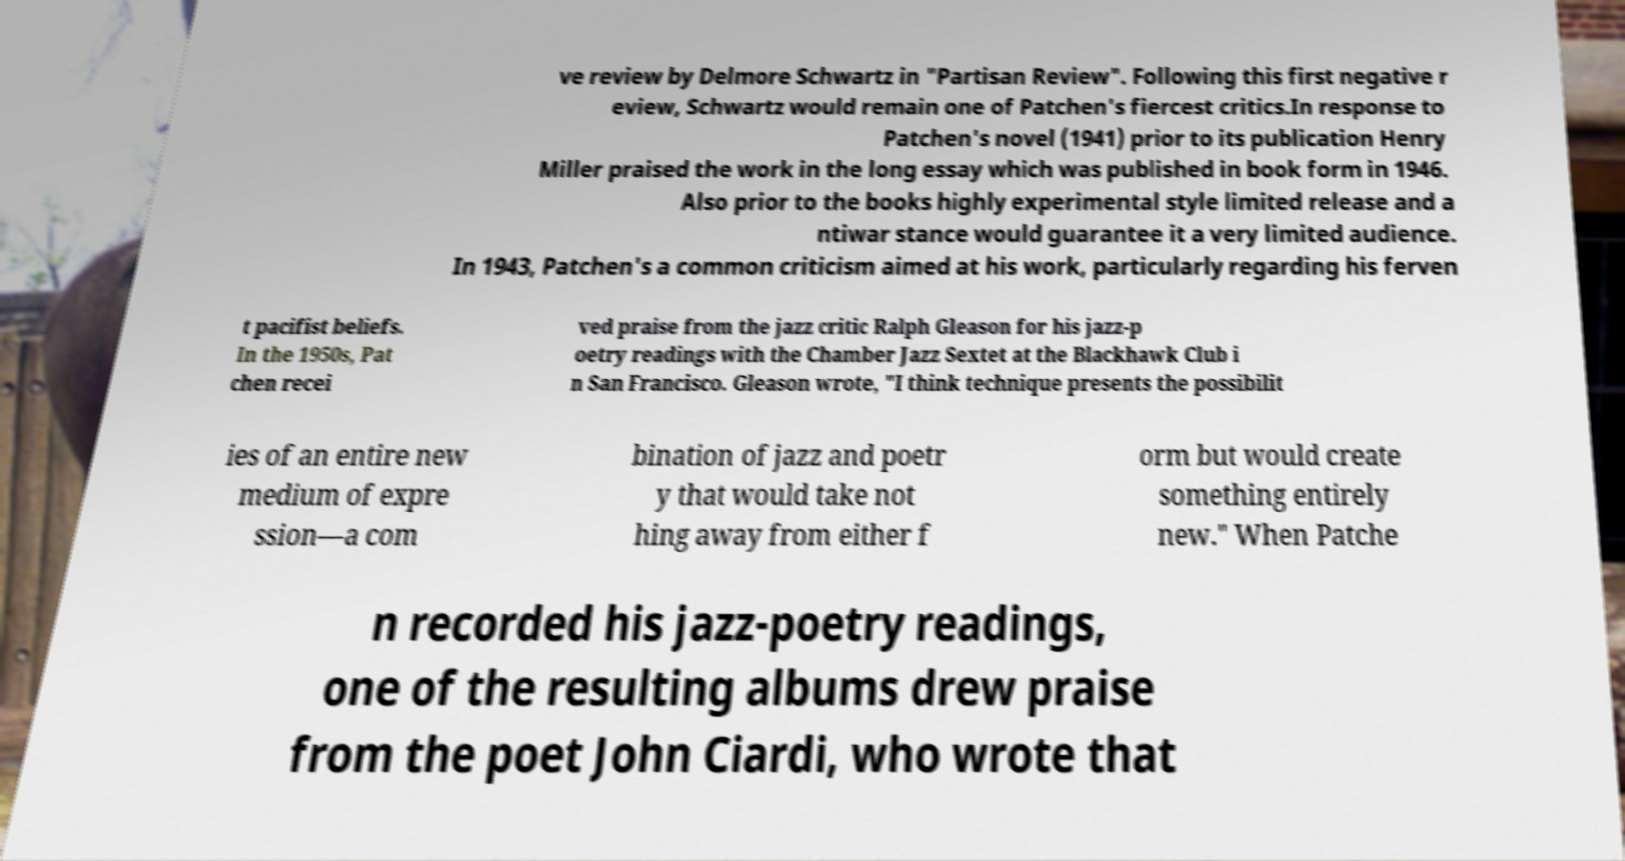I need the written content from this picture converted into text. Can you do that? ve review by Delmore Schwartz in "Partisan Review". Following this first negative r eview, Schwartz would remain one of Patchen's fiercest critics.In response to Patchen's novel (1941) prior to its publication Henry Miller praised the work in the long essay which was published in book form in 1946. Also prior to the books highly experimental style limited release and a ntiwar stance would guarantee it a very limited audience. In 1943, Patchen's a common criticism aimed at his work, particularly regarding his ferven t pacifist beliefs. In the 1950s, Pat chen recei ved praise from the jazz critic Ralph Gleason for his jazz-p oetry readings with the Chamber Jazz Sextet at the Blackhawk Club i n San Francisco. Gleason wrote, "I think technique presents the possibilit ies of an entire new medium of expre ssion―a com bination of jazz and poetr y that would take not hing away from either f orm but would create something entirely new." When Patche n recorded his jazz-poetry readings, one of the resulting albums drew praise from the poet John Ciardi, who wrote that 